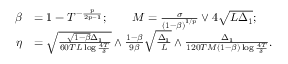Convert formula to latex. <formula><loc_0><loc_0><loc_500><loc_500>\begin{array} { r l } { \beta } & { = 1 - T ^ { - \frac { p } { 2 p - 1 } } ; \quad M = \frac { \sigma } { \left ( 1 - \beta \right ) ^ { 1 / p } } \lor 4 \sqrt { L \Delta _ { 1 } } ; } \\ { \eta } & { = \sqrt { \frac { \sqrt { 1 - \beta } \Delta _ { 1 } } { 6 0 T L \log \frac { 4 T } { \delta } } } \land \frac { 1 - \beta } { 9 \beta } \sqrt { \frac { \Delta _ { 1 } } { L } } \land \frac { \Delta _ { 1 } } { 1 2 0 T M \left ( 1 - \beta \right ) \log \frac { 4 T } { \delta } } . } \end{array}</formula> 